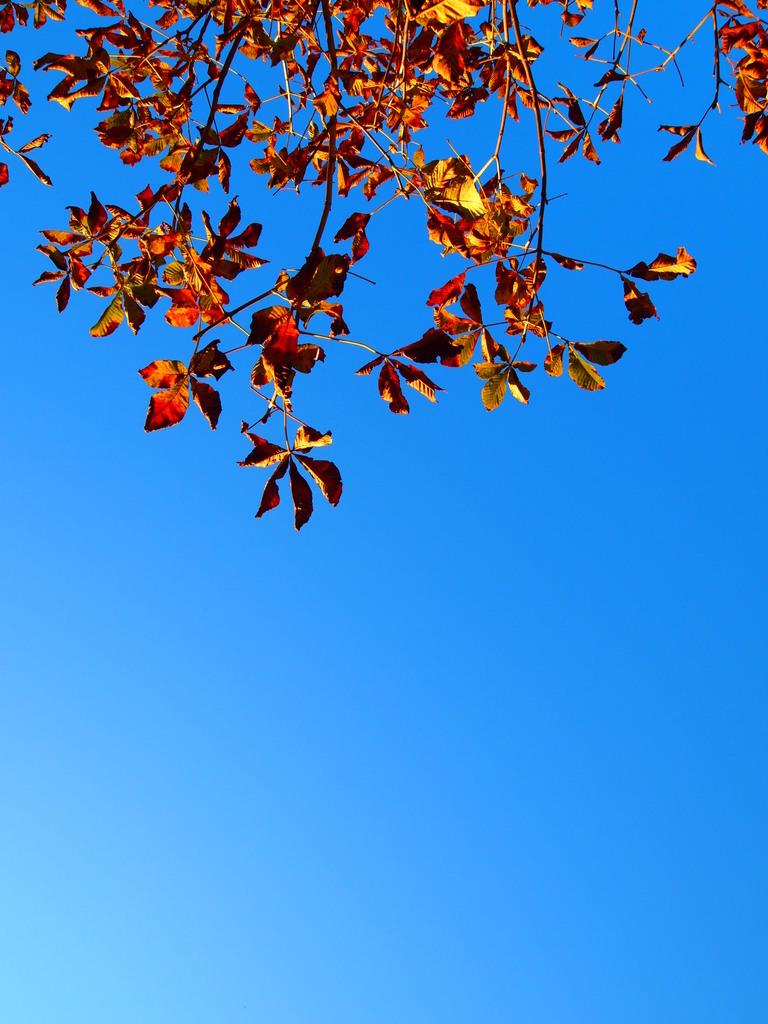What type of vegetation can be seen at the top of the image? There are leaves at the top side of the image. What type of cable is used to control the weather in the image? There is no cable or weather control depicted in the image; it only features leaves at the top side. 